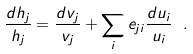Convert formula to latex. <formula><loc_0><loc_0><loc_500><loc_500>\frac { d h _ { j } } { h _ { j } } = \frac { d v _ { j } } { v _ { j } } + \sum _ { i } e _ { j i } \frac { d u _ { i } } { u _ { i } } \ .</formula> 